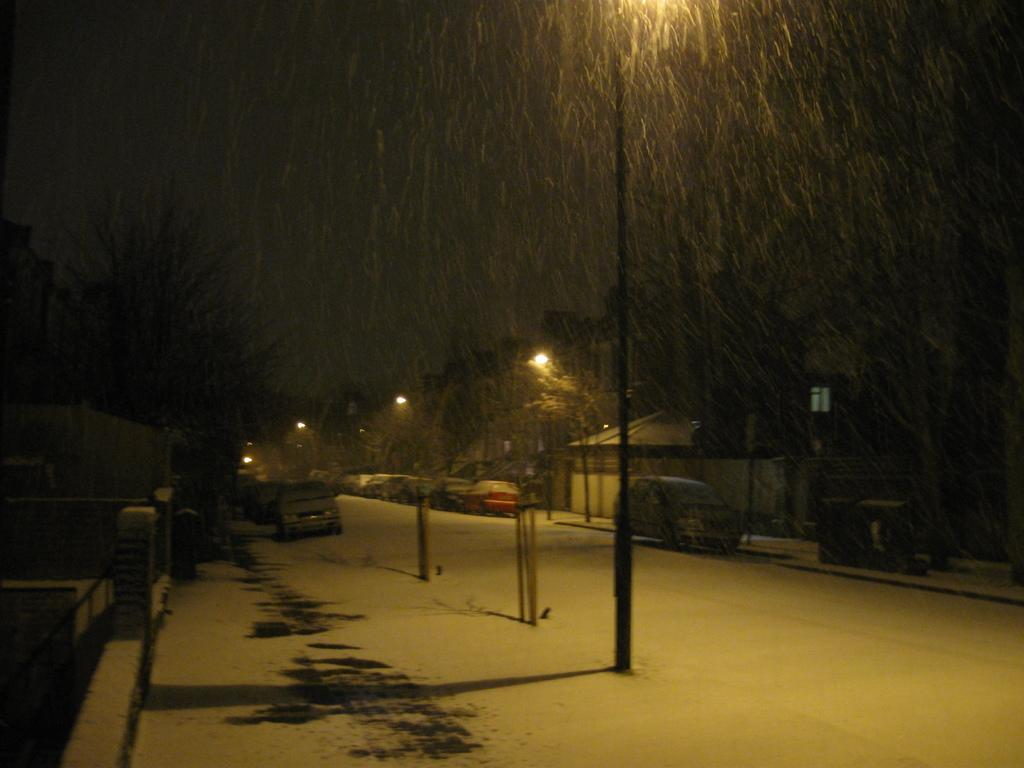What can be seen on the road in the image? There are cars parked on the road in the image. Where are the cars located in relation to the image? The cars are located at the bottom of the image. What type of natural elements can be seen in the image? There are trees visible at the top of the image. What type of list can be seen hanging from the trees in the image? There is no list present in the image; only cars and trees are visible. How many babies are sitting in the cars in the image? There is no information about babies in the image; it only shows parked cars and trees. 